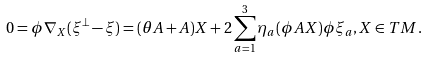Convert formula to latex. <formula><loc_0><loc_0><loc_500><loc_500>0 = \phi \nabla _ { X } ( \xi ^ { \perp } - \xi ) = ( \theta A + A ) X + 2 \sum ^ { 3 } _ { a = 1 } \eta _ { a } ( \phi A X ) \phi \xi _ { a } , X \in T M .</formula> 